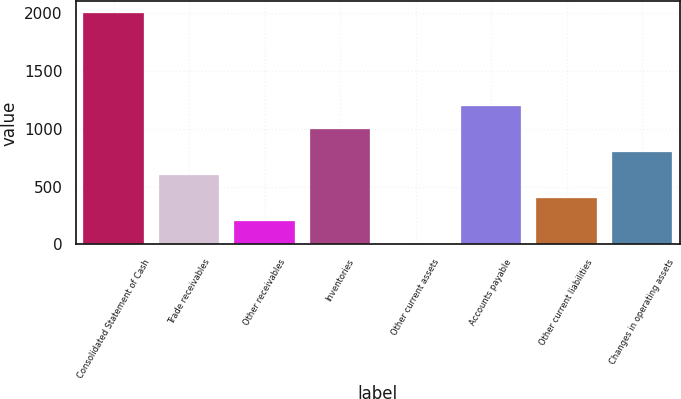Convert chart. <chart><loc_0><loc_0><loc_500><loc_500><bar_chart><fcel>Consolidated Statement of Cash<fcel>Trade receivables<fcel>Other receivables<fcel>Inventories<fcel>Other current assets<fcel>Accounts payable<fcel>Other current liabilities<fcel>Changes in operating assets<nl><fcel>2003<fcel>601.18<fcel>200.66<fcel>1001.7<fcel>0.4<fcel>1201.96<fcel>400.92<fcel>801.44<nl></chart> 